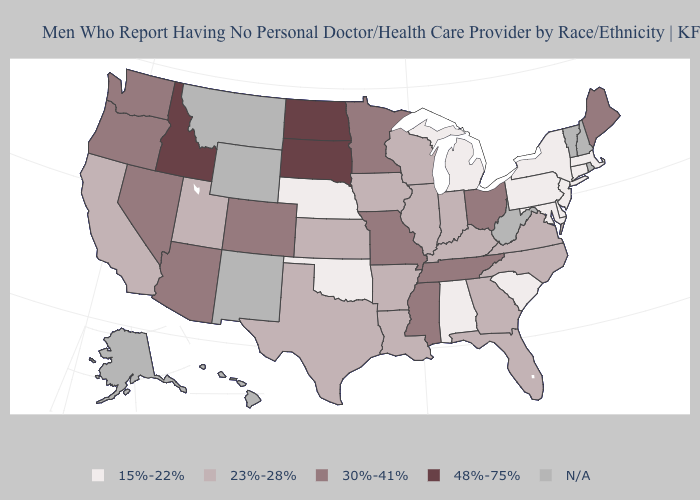Name the states that have a value in the range 30%-41%?
Keep it brief. Arizona, Colorado, Maine, Minnesota, Mississippi, Missouri, Nevada, Ohio, Oregon, Tennessee, Washington. Does the map have missing data?
Write a very short answer. Yes. What is the value of Michigan?
Concise answer only. 15%-22%. Is the legend a continuous bar?
Be succinct. No. Name the states that have a value in the range 23%-28%?
Write a very short answer. Arkansas, California, Florida, Georgia, Illinois, Indiana, Iowa, Kansas, Kentucky, Louisiana, North Carolina, Texas, Utah, Virginia, Wisconsin. What is the value of Mississippi?
Answer briefly. 30%-41%. Does the map have missing data?
Short answer required. Yes. What is the lowest value in the West?
Give a very brief answer. 23%-28%. Name the states that have a value in the range 23%-28%?
Concise answer only. Arkansas, California, Florida, Georgia, Illinois, Indiana, Iowa, Kansas, Kentucky, Louisiana, North Carolina, Texas, Utah, Virginia, Wisconsin. Which states have the lowest value in the USA?
Give a very brief answer. Alabama, Connecticut, Delaware, Maryland, Massachusetts, Michigan, Nebraska, New Jersey, New York, Oklahoma, Pennsylvania, South Carolina. Which states hav the highest value in the South?
Concise answer only. Mississippi, Tennessee. Among the states that border Virginia , which have the highest value?
Answer briefly. Tennessee. Does Oklahoma have the lowest value in the South?
Keep it brief. Yes. 